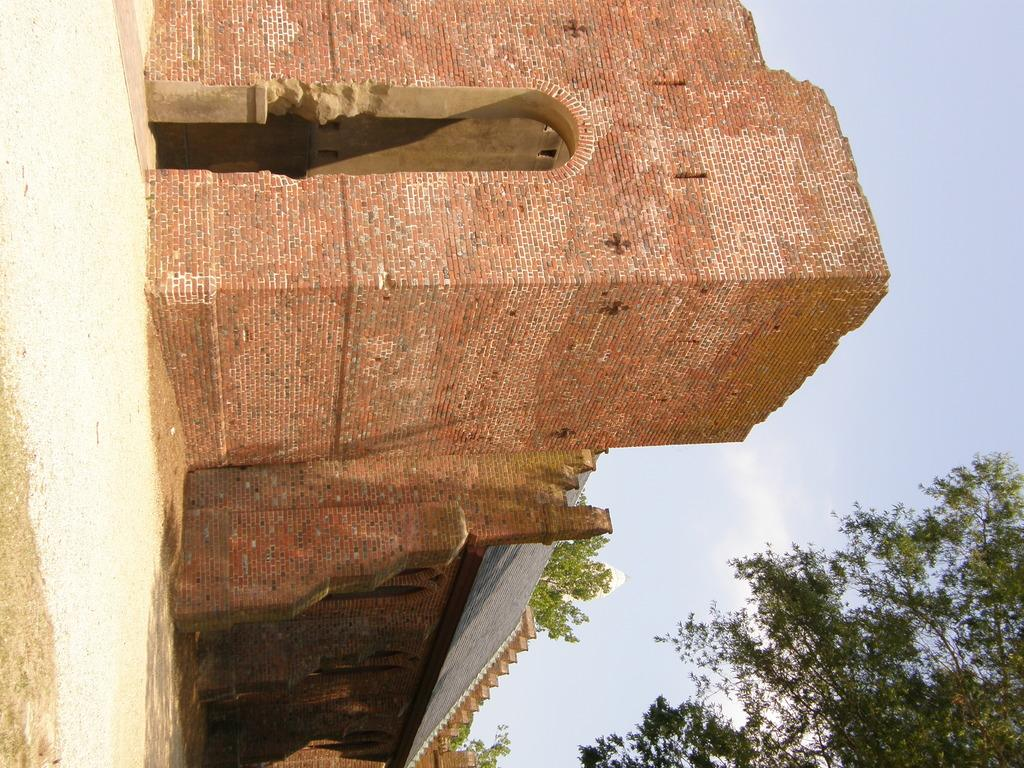What type of building is visible in the image? There is a building with bricks in the image. What is located in front of the building? There is sand in front of the building. What can be seen in the background of the image? There are trees and the sky visible in the background of the image. What is the value of the sand in the image? The value of the sand cannot be determined from the image, as it is not a financial or numerical concept. 